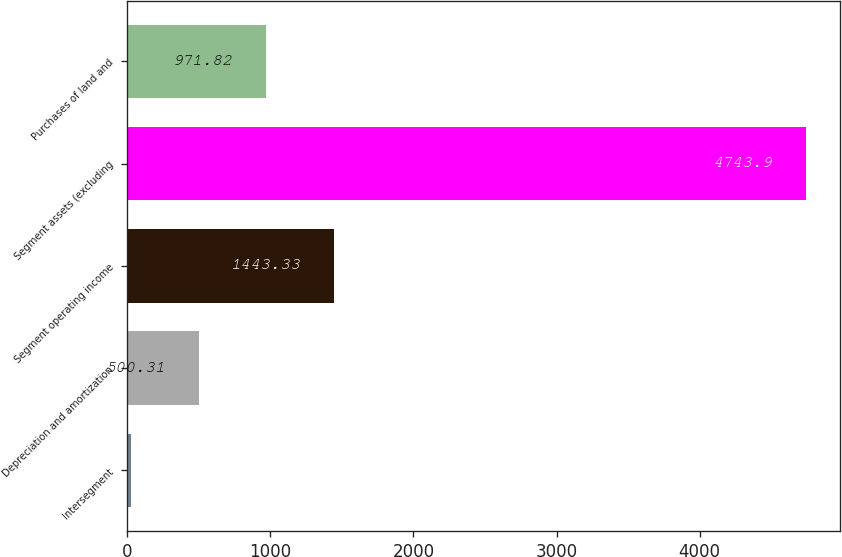Convert chart. <chart><loc_0><loc_0><loc_500><loc_500><bar_chart><fcel>Intersegment<fcel>Depreciation and amortization<fcel>Segment operating income<fcel>Segment assets (excluding<fcel>Purchases of land and<nl><fcel>28.8<fcel>500.31<fcel>1443.33<fcel>4743.9<fcel>971.82<nl></chart> 